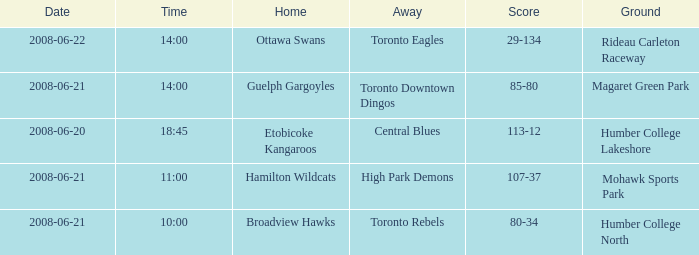What is the Date with a Home that is hamilton wildcats? 2008-06-21. 